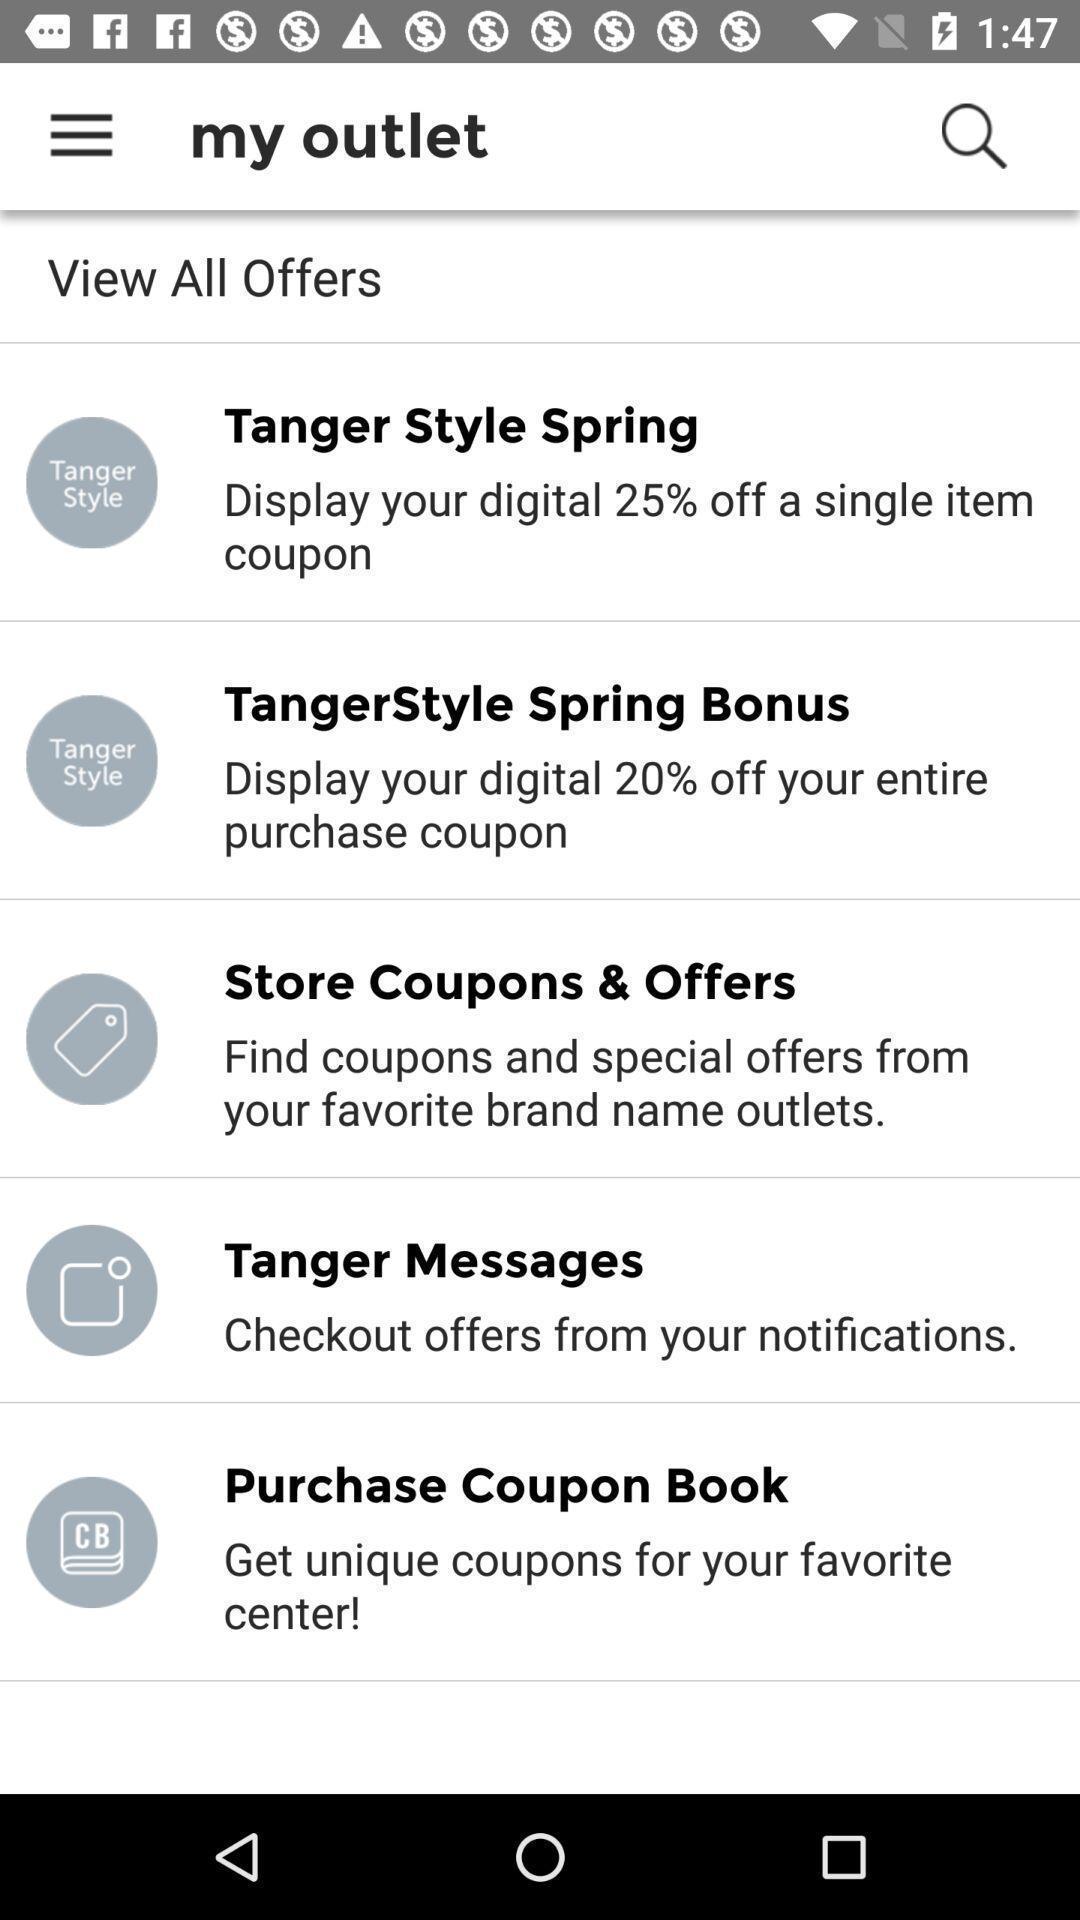Describe this image in words. Page displaying the outlets. 